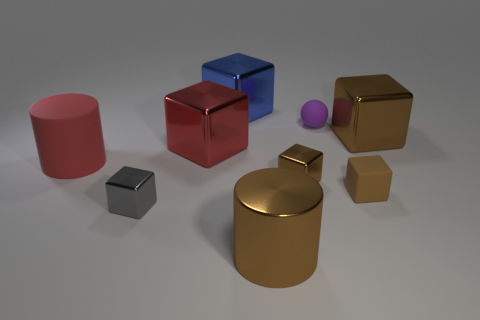Are there any purple objects?
Offer a terse response. Yes. Is the shape of the tiny shiny thing left of the large brown metallic cylinder the same as the big brown metallic object to the right of the large brown cylinder?
Provide a short and direct response. Yes. Are there any large blue blocks made of the same material as the purple thing?
Your answer should be compact. No. Does the big cylinder to the right of the large red cylinder have the same material as the purple thing?
Offer a very short reply. No. Is the number of small rubber blocks that are on the left side of the small purple rubber ball greater than the number of big blue metal cubes to the left of the blue thing?
Provide a short and direct response. No. There is a rubber ball that is the same size as the rubber cube; what color is it?
Ensure brevity in your answer.  Purple. Is there a rubber object of the same color as the rubber ball?
Provide a short and direct response. No. There is a small rubber thing to the left of the tiny brown matte cube; does it have the same color as the large cylinder left of the large blue thing?
Your answer should be compact. No. There is a large red thing that is right of the large rubber cylinder; what is its material?
Make the answer very short. Metal. What is the color of the cylinder that is made of the same material as the red cube?
Offer a very short reply. Brown. 